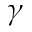Convert formula to latex. <formula><loc_0><loc_0><loc_500><loc_500>\gamma</formula> 